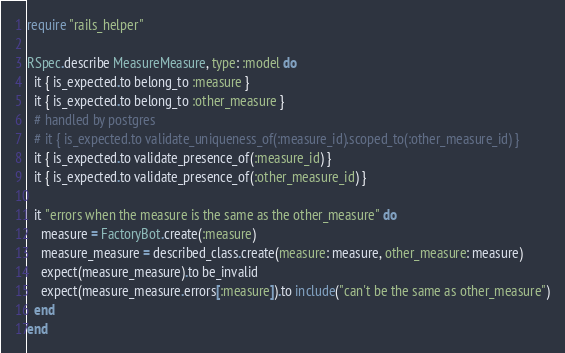<code> <loc_0><loc_0><loc_500><loc_500><_Ruby_>require "rails_helper"

RSpec.describe MeasureMeasure, type: :model do
  it { is_expected.to belong_to :measure }
  it { is_expected.to belong_to :other_measure }
  # handled by postgres
  # it { is_expected.to validate_uniqueness_of(:measure_id).scoped_to(:other_measure_id) }
  it { is_expected.to validate_presence_of(:measure_id) }
  it { is_expected.to validate_presence_of(:other_measure_id) }

  it "errors when the measure is the same as the other_measure" do
    measure = FactoryBot.create(:measure)
    measure_measure = described_class.create(measure: measure, other_measure: measure)
    expect(measure_measure).to be_invalid
    expect(measure_measure.errors[:measure]).to include("can't be the same as other_measure")
  end
end
</code> 